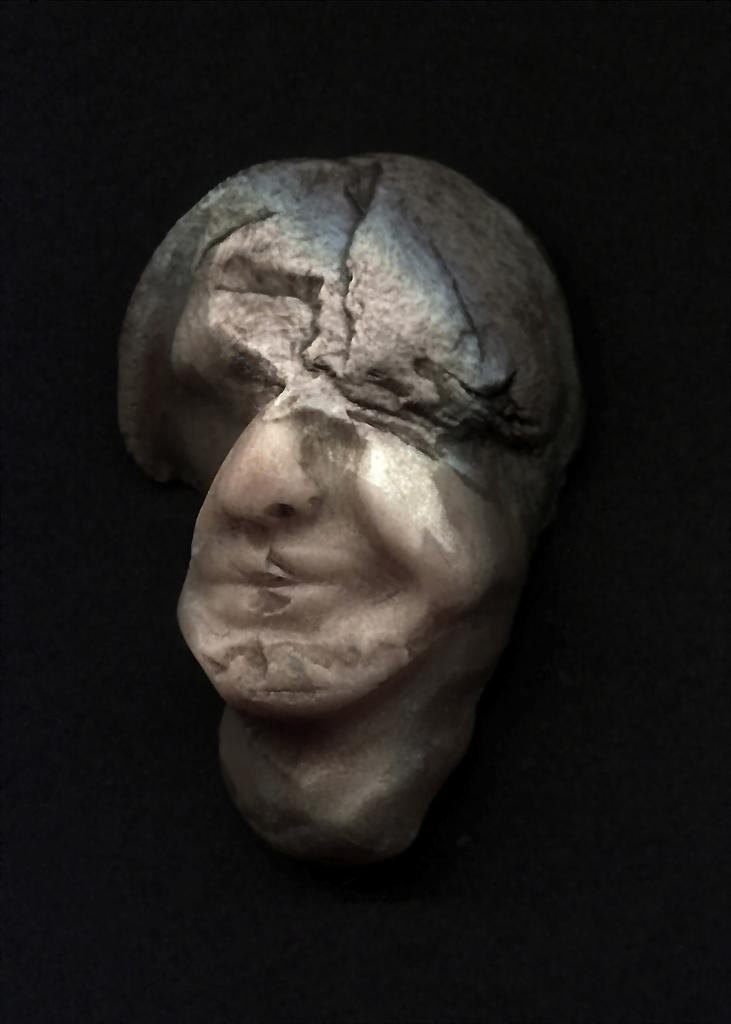What is the main subject of the image? There is a stone sculpture in the image. Can you describe the background of the image? The background of the image is dark. What type of salt can be seen on the letters in the image? There are no letters or salt present in the image; it features a stone sculpture with a dark background. 